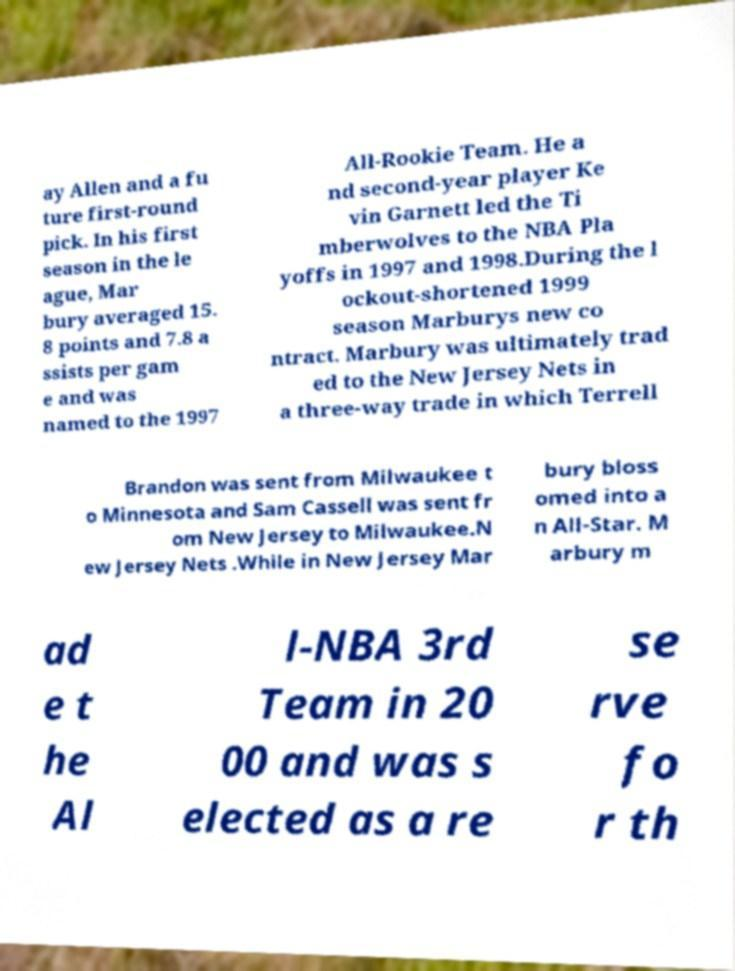Could you extract and type out the text from this image? ay Allen and a fu ture first-round pick. In his first season in the le ague, Mar bury averaged 15. 8 points and 7.8 a ssists per gam e and was named to the 1997 All-Rookie Team. He a nd second-year player Ke vin Garnett led the Ti mberwolves to the NBA Pla yoffs in 1997 and 1998.During the l ockout-shortened 1999 season Marburys new co ntract. Marbury was ultimately trad ed to the New Jersey Nets in a three-way trade in which Terrell Brandon was sent from Milwaukee t o Minnesota and Sam Cassell was sent fr om New Jersey to Milwaukee.N ew Jersey Nets .While in New Jersey Mar bury bloss omed into a n All-Star. M arbury m ad e t he Al l-NBA 3rd Team in 20 00 and was s elected as a re se rve fo r th 